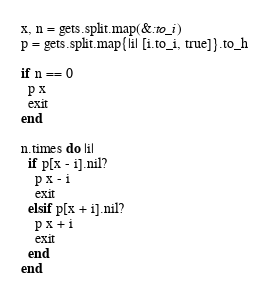Convert code to text. <code><loc_0><loc_0><loc_500><loc_500><_Ruby_>x, n = gets.split.map(&:to_i)
p = gets.split.map{|i| [i.to_i, true]}.to_h

if n == 0
  p x
  exit
end

n.times do |i|
  if p[x - i].nil?
    p x - i
    exit
  elsif p[x + i].nil?
    p x + i
    exit
  end
end</code> 